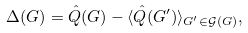<formula> <loc_0><loc_0><loc_500><loc_500>\Delta ( G ) = \hat { Q } ( G ) - \langle \hat { Q } ( G ^ { \prime } ) \rangle _ { G ^ { \prime } \in \mathcal { G } ( G ) } ,</formula> 